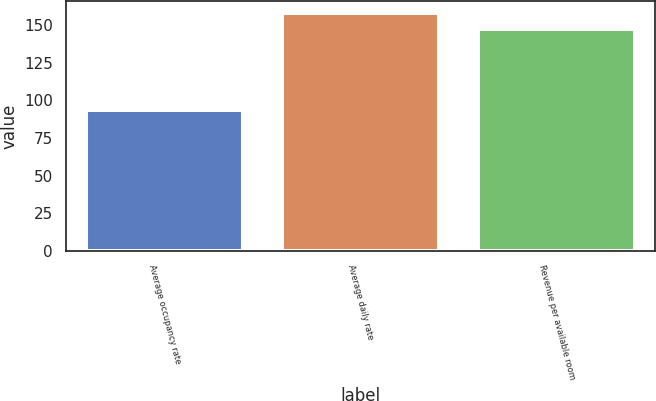Convert chart. <chart><loc_0><loc_0><loc_500><loc_500><bar_chart><fcel>Average occupancy rate<fcel>Average daily rate<fcel>Revenue per available room<nl><fcel>93.4<fcel>158.01<fcel>147.63<nl></chart> 